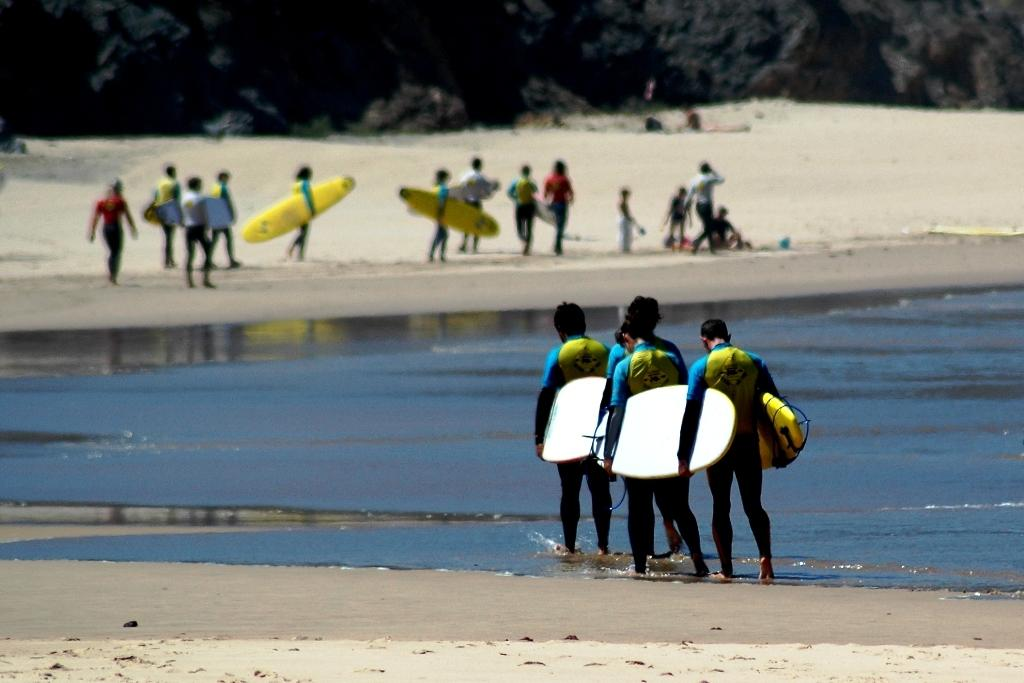Who or what can be seen in the image? There are people in the image. What is present in the image along with the people? There is water and surfboards in the image. What are some people doing with the surfboards? Some people are holding surfboards. Can you describe the background of the image? The background of the image is blurred. What type of kettle can be seen in the image? There is no kettle present in the image. How many songs can be heard playing in the background of the image? There is no audio or music present in the image, so it is not possible to determine the number of songs. 